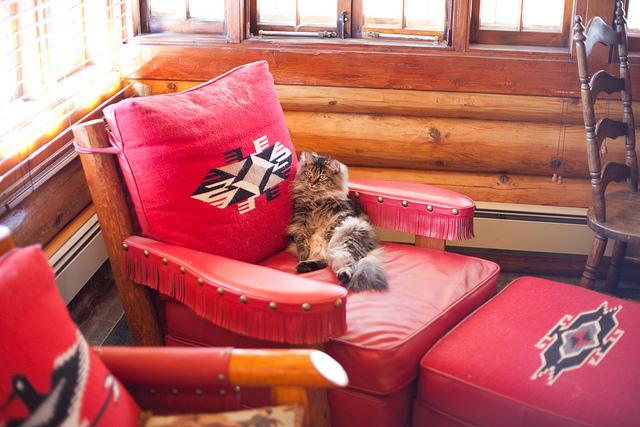What color are the chairs?
Give a very brief answer. Red. What animal is on the chair?
Give a very brief answer. Cat. How many rivet details in the chair arms?
Answer briefly. 10. 